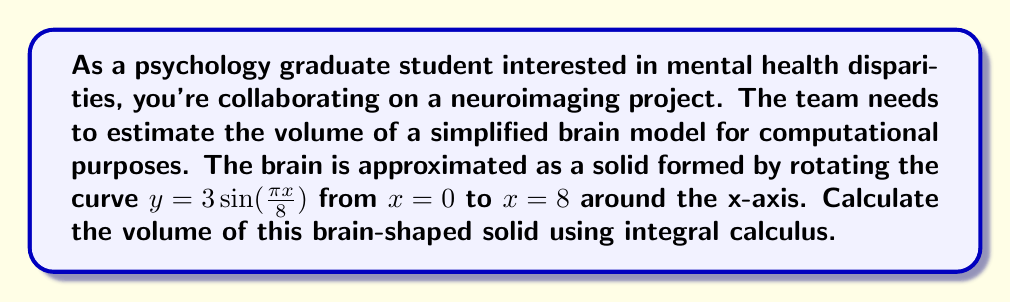Solve this math problem. To solve this problem, we'll use the method of volumes by rotation, specifically the shell method. The steps are as follows:

1) The shell method formula for volume is:

   $$V = 2\pi \int_a^b y(x) \cdot x \, dx$$

   where $y(x)$ is the function being rotated, and $[a,b]$ is the interval of rotation.

2) In this case, $y(x) = 3\sin(\frac{\pi x}{8})$, $a = 0$, and $b = 8$.

3) Substituting these into the formula:

   $$V = 2\pi \int_0^8 3\sin(\frac{\pi x}{8}) \cdot x \, dx$$

4) Simplify the constant:

   $$V = 6\pi \int_0^8 x\sin(\frac{\pi x}{8}) \, dx$$

5) To integrate this, we need to use integration by parts. Let $u = x$ and $dv = \sin(\frac{\pi x}{8}) \, dx$. Then:

   $du = dx$
   $v = -\frac{8}{\pi}\cos(\frac{\pi x}{8})$

6) Applying integration by parts:

   $$V = 6\pi \left[-\frac{8}{\pi}x\cos(\frac{\pi x}{8}) \right]_0^8 + 6\pi \int_0^8 \frac{8}{\pi}\cos(\frac{\pi x}{8}) \, dx$$

7) Evaluate the first term:

   $$V = 6\pi \left[-\frac{8}{\pi} \cdot 8 \cdot \cos(\pi) - (-\frac{8}{\pi} \cdot 0 \cdot \cos(0))\right] + 6\pi \int_0^8 \frac{8}{\pi}\cos(\frac{\pi x}{8}) \, dx$$
   $$V = 6\pi \left[\frac{64}{\pi}\right] + 6\pi \int_0^8 \frac{8}{\pi}\cos(\frac{\pi x}{8}) \, dx$$

8) For the remaining integral, let $w = \frac{\pi x}{8}$. Then $dw = \frac{\pi}{8} dx$, or $dx = \frac{8}{\pi} dw$:

   $$V = \frac{384}{\pi} + 48 \int_0^\pi \cos(w) \, dw$$

9) Evaluate this integral:

   $$V = \frac{384}{\pi} + 48 [\sin(w)]_0^\pi = \frac{384}{\pi} + 48 [0 - 0] = \frac{384}{\pi}$$

Therefore, the volume of the brain-shaped solid is $\frac{384}{\pi}$ cubic units.
Answer: $\frac{384}{\pi}$ cubic units 